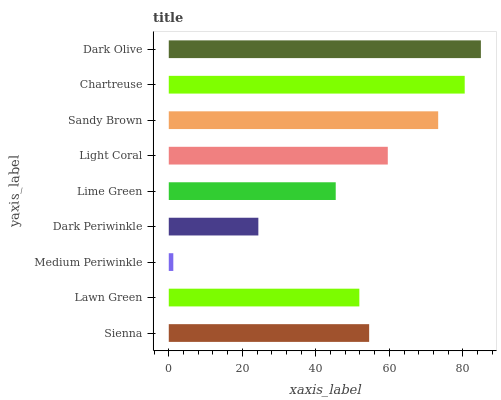Is Medium Periwinkle the minimum?
Answer yes or no. Yes. Is Dark Olive the maximum?
Answer yes or no. Yes. Is Lawn Green the minimum?
Answer yes or no. No. Is Lawn Green the maximum?
Answer yes or no. No. Is Sienna greater than Lawn Green?
Answer yes or no. Yes. Is Lawn Green less than Sienna?
Answer yes or no. Yes. Is Lawn Green greater than Sienna?
Answer yes or no. No. Is Sienna less than Lawn Green?
Answer yes or no. No. Is Sienna the high median?
Answer yes or no. Yes. Is Sienna the low median?
Answer yes or no. Yes. Is Light Coral the high median?
Answer yes or no. No. Is Sandy Brown the low median?
Answer yes or no. No. 